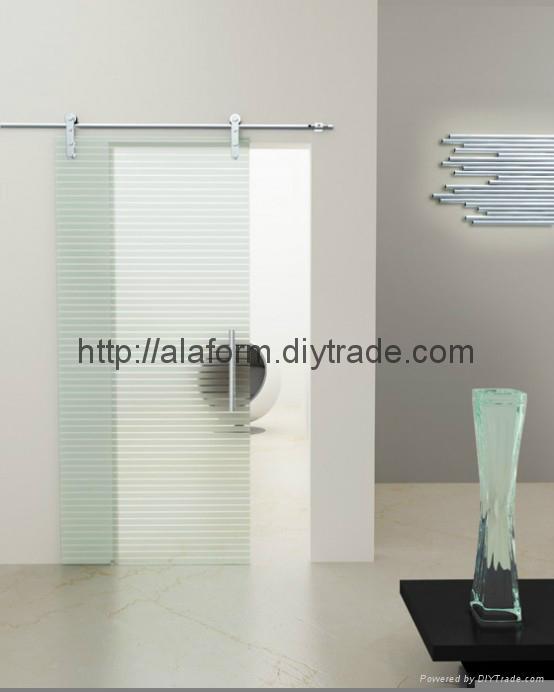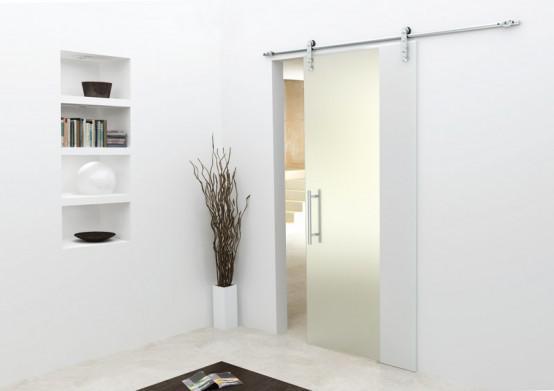The first image is the image on the left, the second image is the image on the right. Given the left and right images, does the statement "The image on the right contains a potted plant" hold true? Answer yes or no. Yes. 